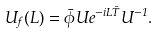<formula> <loc_0><loc_0><loc_500><loc_500>U _ { f } ( L ) = \bar { \phi } U e ^ { - i L \bar { T } } U ^ { - 1 } .</formula> 